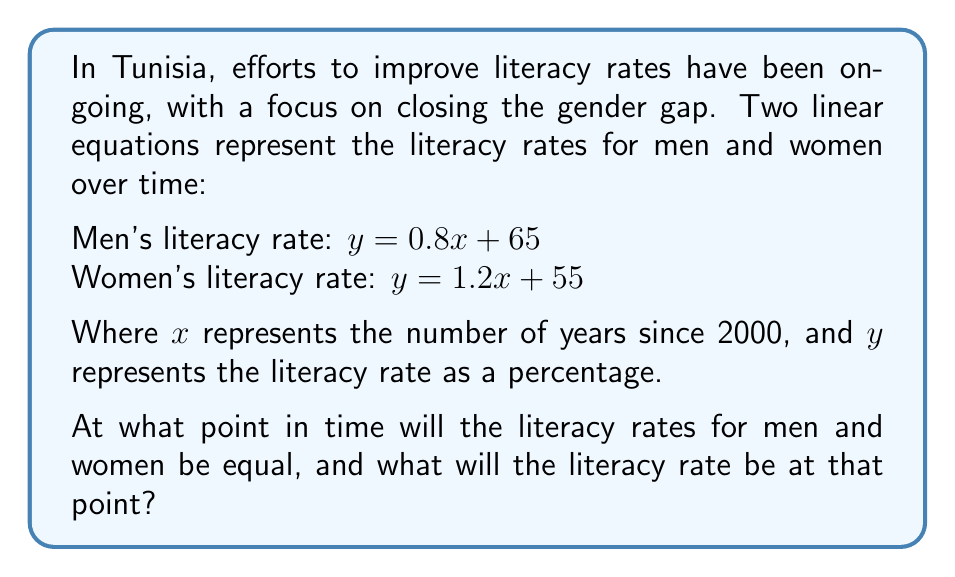Help me with this question. To solve this problem, we need to find the intersection point of the two lines representing men's and women's literacy rates. This point will indicate when the rates are equal.

1) We have two equations:
   Men: $y = 0.8x + 65$
   Women: $y = 1.2x + 55$

2) At the intersection point, the $y$ values will be equal, so we can set the equations equal to each other:
   $0.8x + 65 = 1.2x + 55$

3) Subtract $0.8x$ from both sides:
   $65 = 0.4x + 55$

4) Subtract 55 from both sides:
   $10 = 0.4x$

5) Divide both sides by 0.4:
   $25 = x$

6) This means the intersection occurs 25 years after 2000, which is the year 2025.

7) To find the literacy rate at this point, we can substitute $x = 25$ into either of the original equations. Let's use the men's equation:
   $y = 0.8(25) + 65 = 20 + 65 = 85$

Therefore, in 2025, both men's and women's literacy rates will be 85%.

[asy]
import graph;
size(200,200);

xaxis("Years since 2000",arrow=Arrow);
yaxis("Literacy rate (%)",arrow=Arrow);

real f(real x) {return 0.8x + 65;}
real g(real x) {return 1.2x + 55;}

draw(graph(f,0,30),blue);
draw(graph(g,0,30),red);

dot((25,85),black);
label("(25, 85)",(25,85),NE);

label("Men",(-2,70),blue);
label("Women",(-2,60),red);
[/asy]
Answer: The literacy rates for men and women in Tunisia will be equal in the year 2025 (25 years after 2000), at which point the literacy rate for both genders will be 85%. 